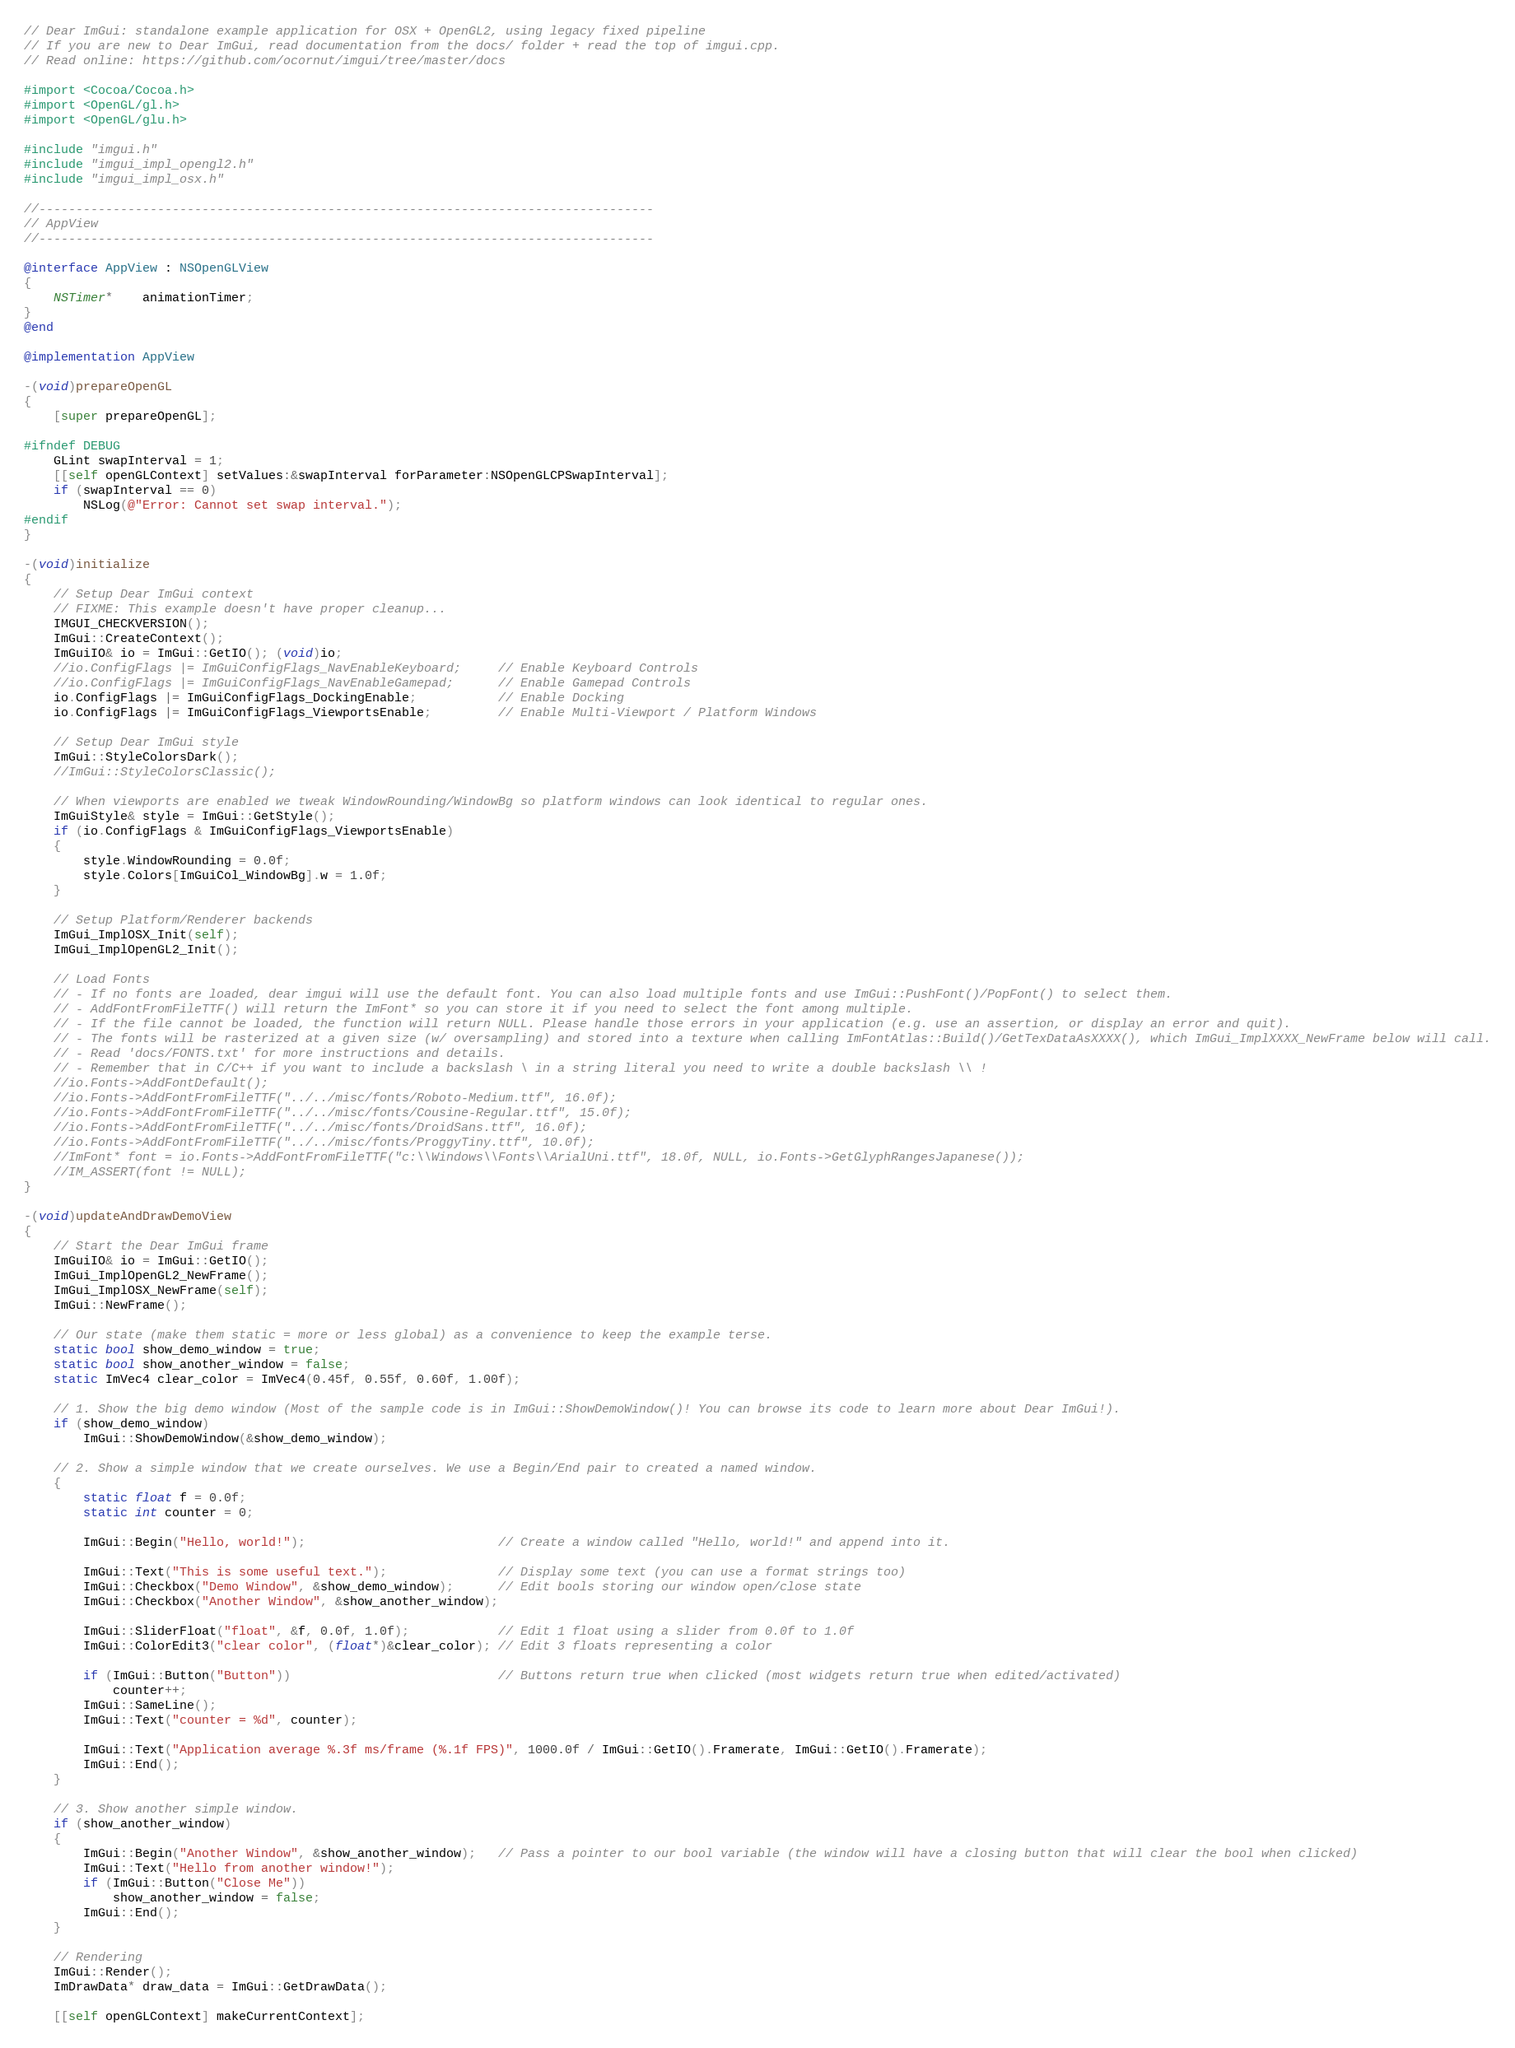<code> <loc_0><loc_0><loc_500><loc_500><_ObjectiveC_>// Dear ImGui: standalone example application for OSX + OpenGL2, using legacy fixed pipeline
// If you are new to Dear ImGui, read documentation from the docs/ folder + read the top of imgui.cpp.
// Read online: https://github.com/ocornut/imgui/tree/master/docs

#import <Cocoa/Cocoa.h>
#import <OpenGL/gl.h>
#import <OpenGL/glu.h>

#include "imgui.h"
#include "imgui_impl_opengl2.h"
#include "imgui_impl_osx.h"

//-----------------------------------------------------------------------------------
// AppView
//-----------------------------------------------------------------------------------

@interface AppView : NSOpenGLView
{
    NSTimer*    animationTimer;
}
@end

@implementation AppView

-(void)prepareOpenGL
{
    [super prepareOpenGL];

#ifndef DEBUG
    GLint swapInterval = 1;
    [[self openGLContext] setValues:&swapInterval forParameter:NSOpenGLCPSwapInterval];
    if (swapInterval == 0)
        NSLog(@"Error: Cannot set swap interval.");
#endif
}

-(void)initialize
{
    // Setup Dear ImGui context
    // FIXME: This example doesn't have proper cleanup...
    IMGUI_CHECKVERSION();
    ImGui::CreateContext();
    ImGuiIO& io = ImGui::GetIO(); (void)io;
    //io.ConfigFlags |= ImGuiConfigFlags_NavEnableKeyboard;     // Enable Keyboard Controls
    //io.ConfigFlags |= ImGuiConfigFlags_NavEnableGamepad;      // Enable Gamepad Controls
    io.ConfigFlags |= ImGuiConfigFlags_DockingEnable;           // Enable Docking
    io.ConfigFlags |= ImGuiConfigFlags_ViewportsEnable;         // Enable Multi-Viewport / Platform Windows

    // Setup Dear ImGui style
    ImGui::StyleColorsDark();
    //ImGui::StyleColorsClassic();

    // When viewports are enabled we tweak WindowRounding/WindowBg so platform windows can look identical to regular ones.
    ImGuiStyle& style = ImGui::GetStyle();
    if (io.ConfigFlags & ImGuiConfigFlags_ViewportsEnable)
    {
        style.WindowRounding = 0.0f;
        style.Colors[ImGuiCol_WindowBg].w = 1.0f;
    }

    // Setup Platform/Renderer backends
    ImGui_ImplOSX_Init(self);
    ImGui_ImplOpenGL2_Init();

    // Load Fonts
    // - If no fonts are loaded, dear imgui will use the default font. You can also load multiple fonts and use ImGui::PushFont()/PopFont() to select them.
    // - AddFontFromFileTTF() will return the ImFont* so you can store it if you need to select the font among multiple.
    // - If the file cannot be loaded, the function will return NULL. Please handle those errors in your application (e.g. use an assertion, or display an error and quit).
    // - The fonts will be rasterized at a given size (w/ oversampling) and stored into a texture when calling ImFontAtlas::Build()/GetTexDataAsXXXX(), which ImGui_ImplXXXX_NewFrame below will call.
    // - Read 'docs/FONTS.txt' for more instructions and details.
    // - Remember that in C/C++ if you want to include a backslash \ in a string literal you need to write a double backslash \\ !
    //io.Fonts->AddFontDefault();
    //io.Fonts->AddFontFromFileTTF("../../misc/fonts/Roboto-Medium.ttf", 16.0f);
    //io.Fonts->AddFontFromFileTTF("../../misc/fonts/Cousine-Regular.ttf", 15.0f);
    //io.Fonts->AddFontFromFileTTF("../../misc/fonts/DroidSans.ttf", 16.0f);
    //io.Fonts->AddFontFromFileTTF("../../misc/fonts/ProggyTiny.ttf", 10.0f);
    //ImFont* font = io.Fonts->AddFontFromFileTTF("c:\\Windows\\Fonts\\ArialUni.ttf", 18.0f, NULL, io.Fonts->GetGlyphRangesJapanese());
    //IM_ASSERT(font != NULL);
}

-(void)updateAndDrawDemoView
{
    // Start the Dear ImGui frame
    ImGuiIO& io = ImGui::GetIO();
    ImGui_ImplOpenGL2_NewFrame();
    ImGui_ImplOSX_NewFrame(self);
    ImGui::NewFrame();

    // Our state (make them static = more or less global) as a convenience to keep the example terse.
    static bool show_demo_window = true;
    static bool show_another_window = false;
    static ImVec4 clear_color = ImVec4(0.45f, 0.55f, 0.60f, 1.00f);

    // 1. Show the big demo window (Most of the sample code is in ImGui::ShowDemoWindow()! You can browse its code to learn more about Dear ImGui!).
    if (show_demo_window)
        ImGui::ShowDemoWindow(&show_demo_window);

    // 2. Show a simple window that we create ourselves. We use a Begin/End pair to created a named window.
    {
        static float f = 0.0f;
        static int counter = 0;

        ImGui::Begin("Hello, world!");                          // Create a window called "Hello, world!" and append into it.

        ImGui::Text("This is some useful text.");               // Display some text (you can use a format strings too)
        ImGui::Checkbox("Demo Window", &show_demo_window);      // Edit bools storing our window open/close state
        ImGui::Checkbox("Another Window", &show_another_window);

        ImGui::SliderFloat("float", &f, 0.0f, 1.0f);            // Edit 1 float using a slider from 0.0f to 1.0f
        ImGui::ColorEdit3("clear color", (float*)&clear_color); // Edit 3 floats representing a color

        if (ImGui::Button("Button"))                            // Buttons return true when clicked (most widgets return true when edited/activated)
            counter++;
        ImGui::SameLine();
        ImGui::Text("counter = %d", counter);

        ImGui::Text("Application average %.3f ms/frame (%.1f FPS)", 1000.0f / ImGui::GetIO().Framerate, ImGui::GetIO().Framerate);
        ImGui::End();
    }

    // 3. Show another simple window.
    if (show_another_window)
    {
        ImGui::Begin("Another Window", &show_another_window);   // Pass a pointer to our bool variable (the window will have a closing button that will clear the bool when clicked)
        ImGui::Text("Hello from another window!");
        if (ImGui::Button("Close Me"))
            show_another_window = false;
        ImGui::End();
    }

    // Rendering
    ImGui::Render();
    ImDrawData* draw_data = ImGui::GetDrawData();

    [[self openGLContext] makeCurrentContext];</code> 